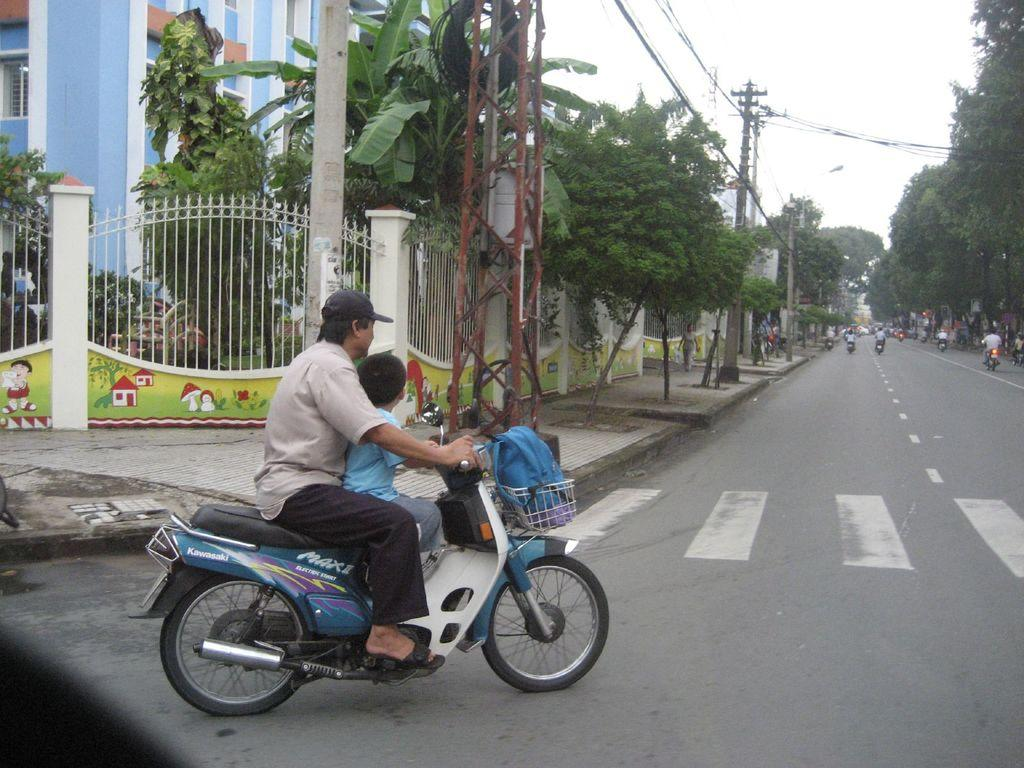Where was the image taken? The image is taken outdoors. What is the man doing in the image? The man is riding a bike in the image. On what surface is the man riding the bike? The man is on a road. What can be seen behind the man in the image? There is a fencing, a tree, and a building behind the man in the image. What type of chin is visible on the queen in the image? There is no queen or chin present in the image; it features a man riding a bike outdoors. 